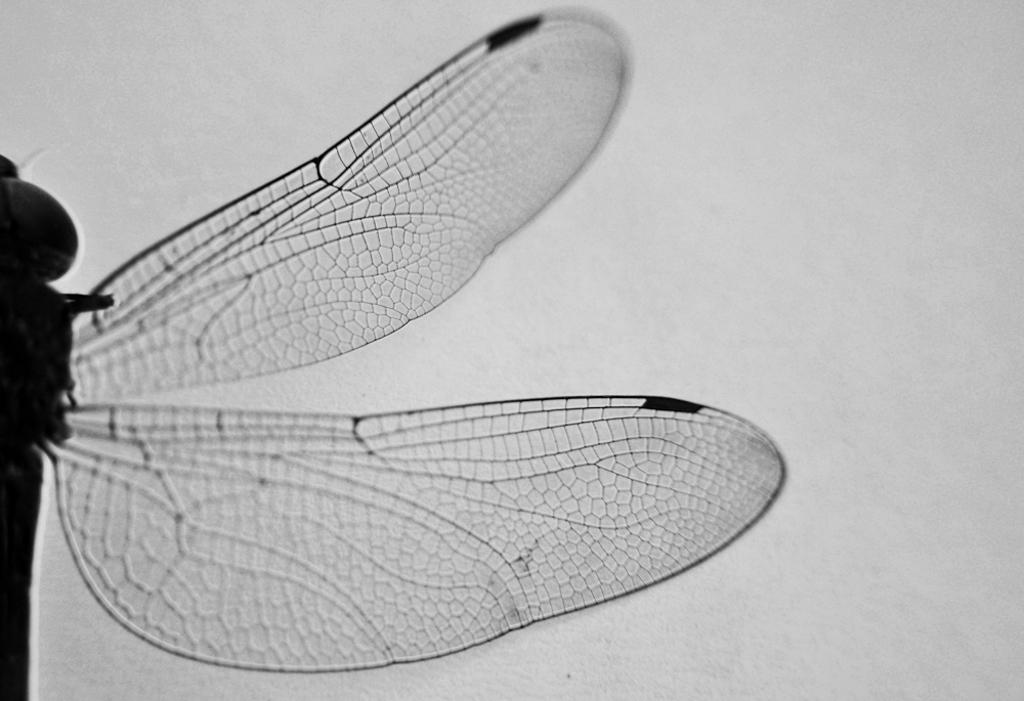What type of creature is present in the image? There is an insect in the image. What specific feature can be observed on the insect? The insect has wings. What type of trade is the insect involved in within the image? There is no indication of any trade activity involving the insect in the image. What type of pot is the insect sitting on in the image? There is no pot present in the image; it only features an insect with wings. 